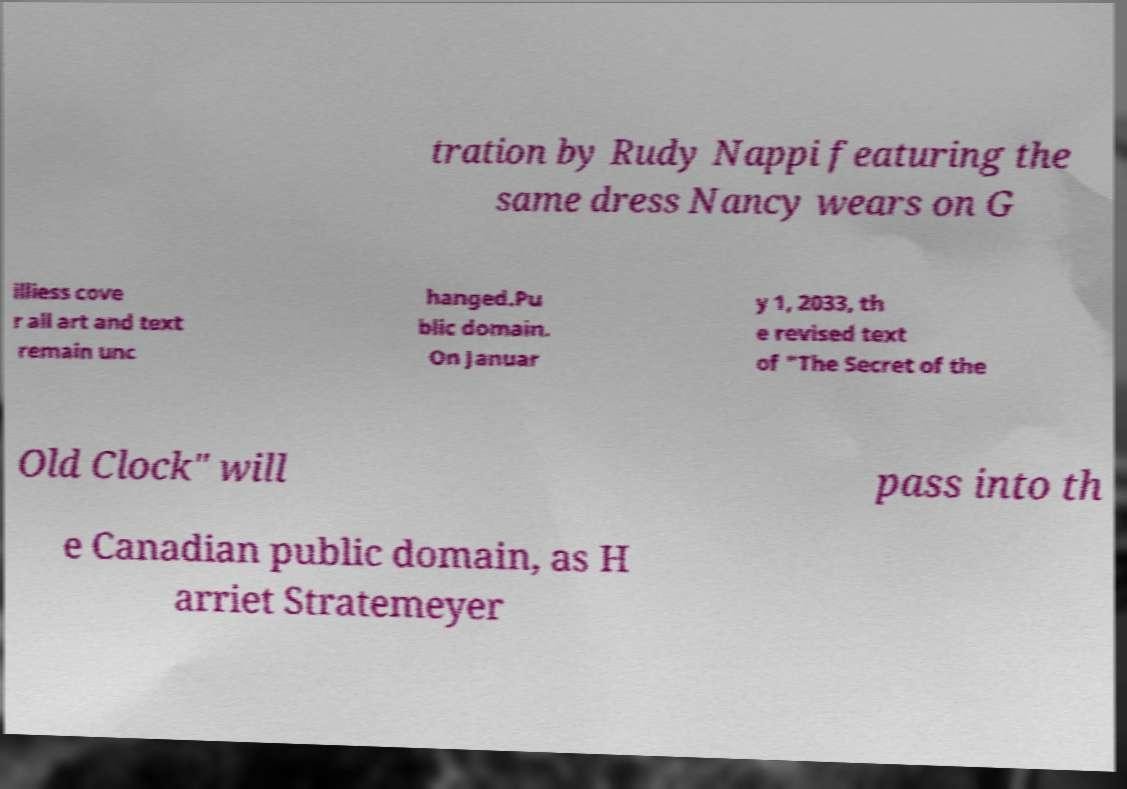Can you accurately transcribe the text from the provided image for me? tration by Rudy Nappi featuring the same dress Nancy wears on G illiess cove r all art and text remain unc hanged.Pu blic domain. On Januar y 1, 2033, th e revised text of "The Secret of the Old Clock" will pass into th e Canadian public domain, as H arriet Stratemeyer 